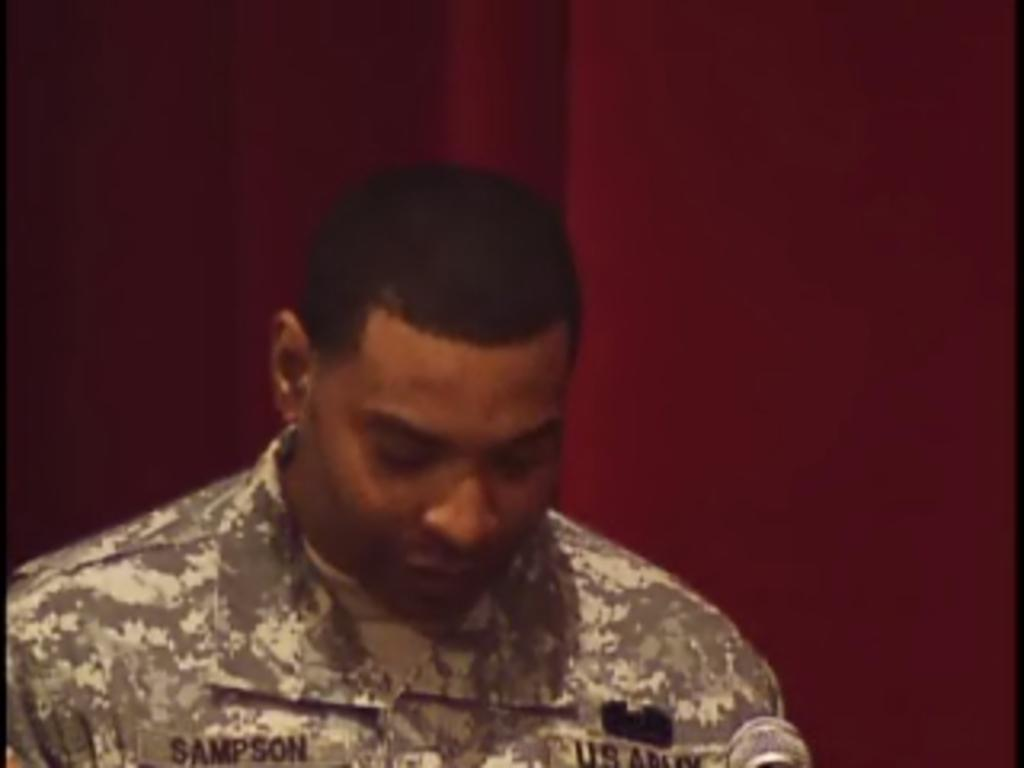What is the main subject in the foreground of the picture? There is a person in the foreground of the picture. What type of clothing is the person wearing? The person is wearing an army dress. What can be seen in the background of the picture? There is a red-colored curtain in the background of the picture. What type of pipe is the person holding in the image? There is no pipe present in the image; the person is wearing an army dress. How many hammers can be seen in the image? There are no hammers present in the image. 